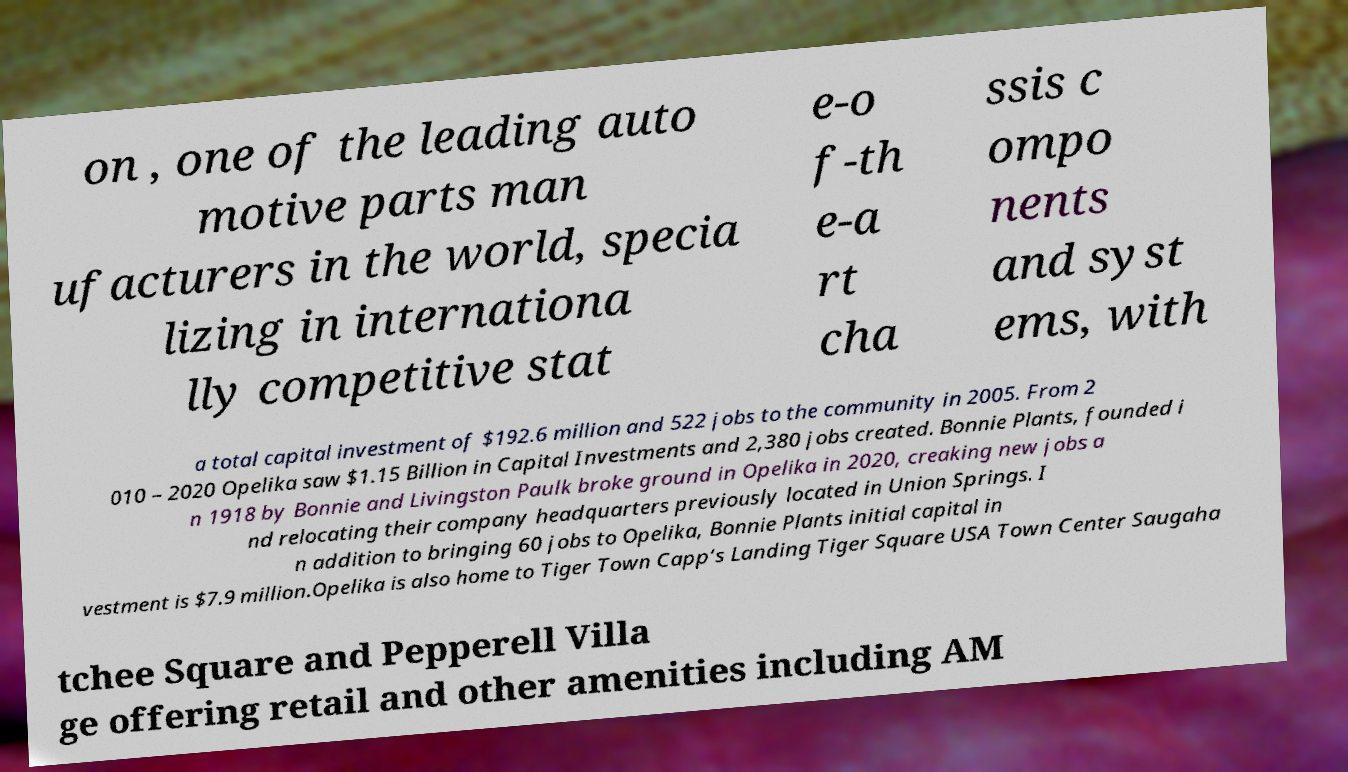For documentation purposes, I need the text within this image transcribed. Could you provide that? on , one of the leading auto motive parts man ufacturers in the world, specia lizing in internationa lly competitive stat e-o f-th e-a rt cha ssis c ompo nents and syst ems, with a total capital investment of $192.6 million and 522 jobs to the community in 2005. From 2 010 – 2020 Opelika saw $1.15 Billion in Capital Investments and 2,380 jobs created. Bonnie Plants, founded i n 1918 by Bonnie and Livingston Paulk broke ground in Opelika in 2020, creaking new jobs a nd relocating their company headquarters previously located in Union Springs. I n addition to bringing 60 jobs to Opelika, Bonnie Plants initial capital in vestment is $7.9 million.Opelika is also home to Tiger Town Capp’s Landing Tiger Square USA Town Center Saugaha tchee Square and Pepperell Villa ge offering retail and other amenities including AM 